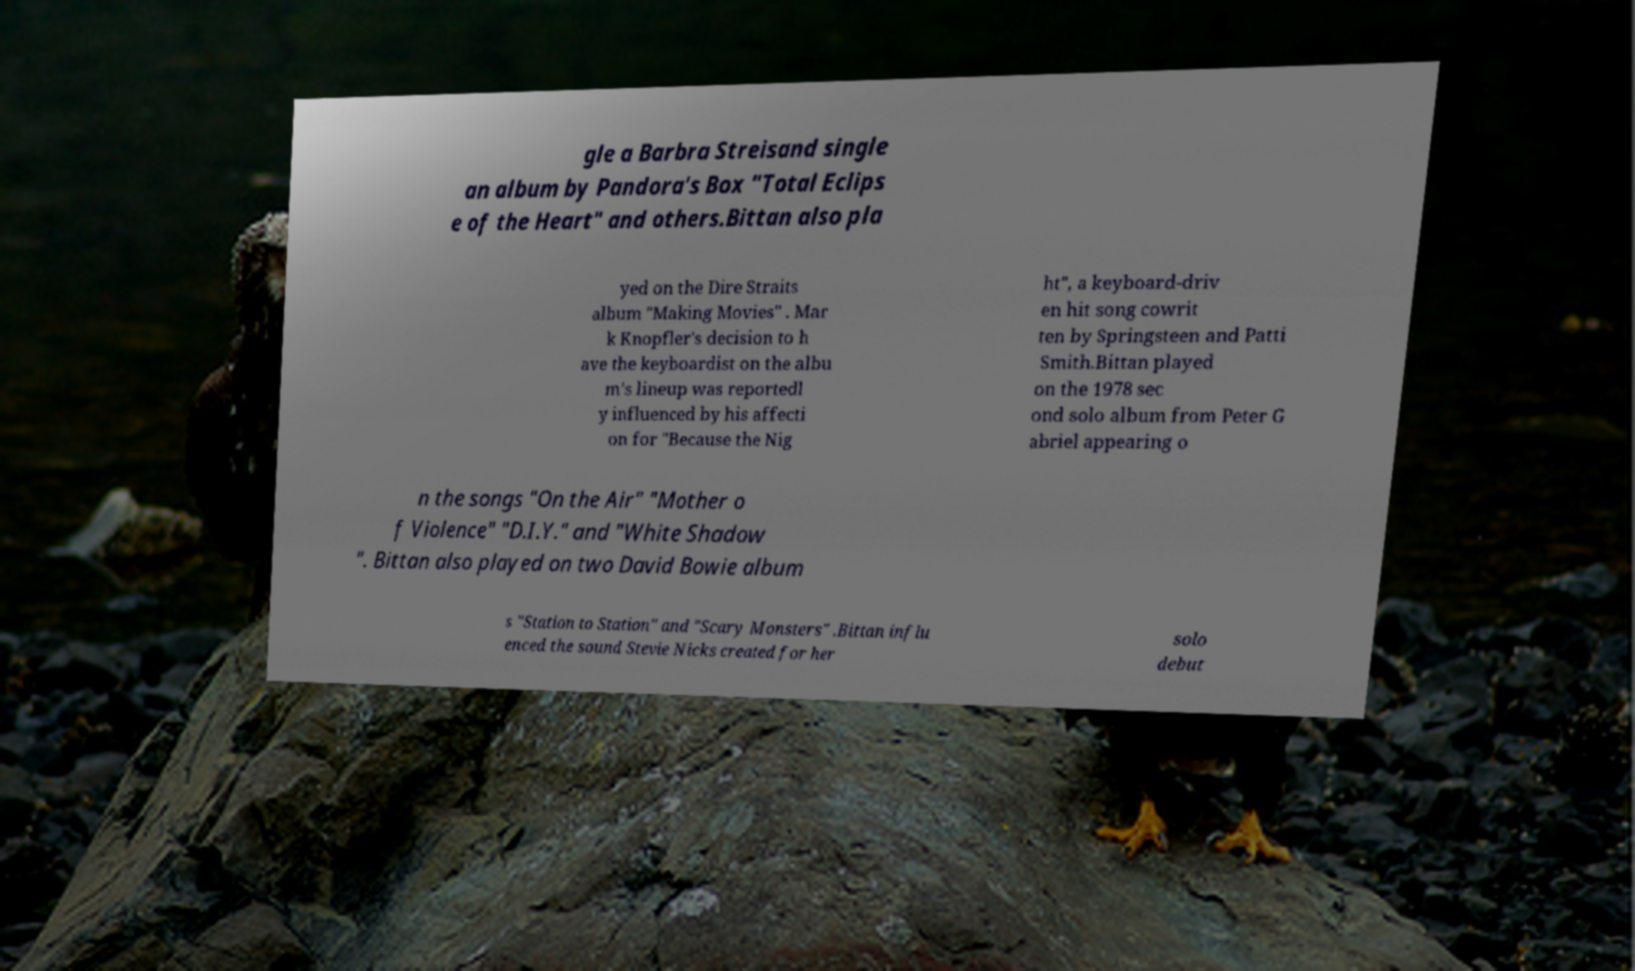I need the written content from this picture converted into text. Can you do that? gle a Barbra Streisand single an album by Pandora's Box "Total Eclips e of the Heart" and others.Bittan also pla yed on the Dire Straits album "Making Movies" . Mar k Knopfler's decision to h ave the keyboardist on the albu m's lineup was reportedl y influenced by his affecti on for "Because the Nig ht", a keyboard-driv en hit song cowrit ten by Springsteen and Patti Smith.Bittan played on the 1978 sec ond solo album from Peter G abriel appearing o n the songs "On the Air" "Mother o f Violence" "D.I.Y." and "White Shadow ". Bittan also played on two David Bowie album s "Station to Station" and "Scary Monsters" .Bittan influ enced the sound Stevie Nicks created for her solo debut 